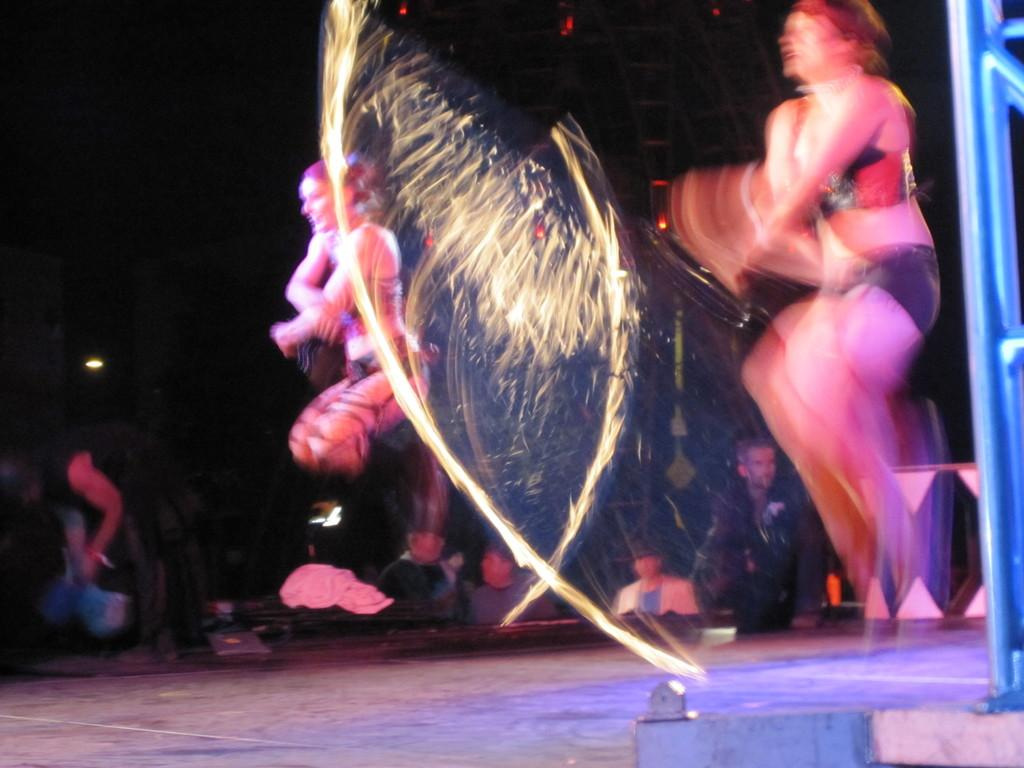How many people are performing in the image? There are two women in the image. What are the women doing in the image? The women are performing a dance. Where is the dance taking place? The dance is taking place on a stage. Who is watching the performance? There is an audience in the image, and they are watching the performance. What type of government is depicted in the image? There is no depiction of a government in the image; it features two women dancing on a stage with an audience watching. Can you tell me how many goldfish are swimming in the background of the image? There are no goldfish present in the image; it focuses on the dance performance and the audience. 